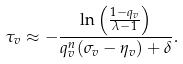<formula> <loc_0><loc_0><loc_500><loc_500>\tau _ { v } \approx - \frac { \ln \left ( \frac { 1 - q _ { v } } { \lambda - 1 } \right ) } { q _ { v } ^ { n } ( \sigma _ { v } - \eta _ { v } ) + \delta } .</formula> 